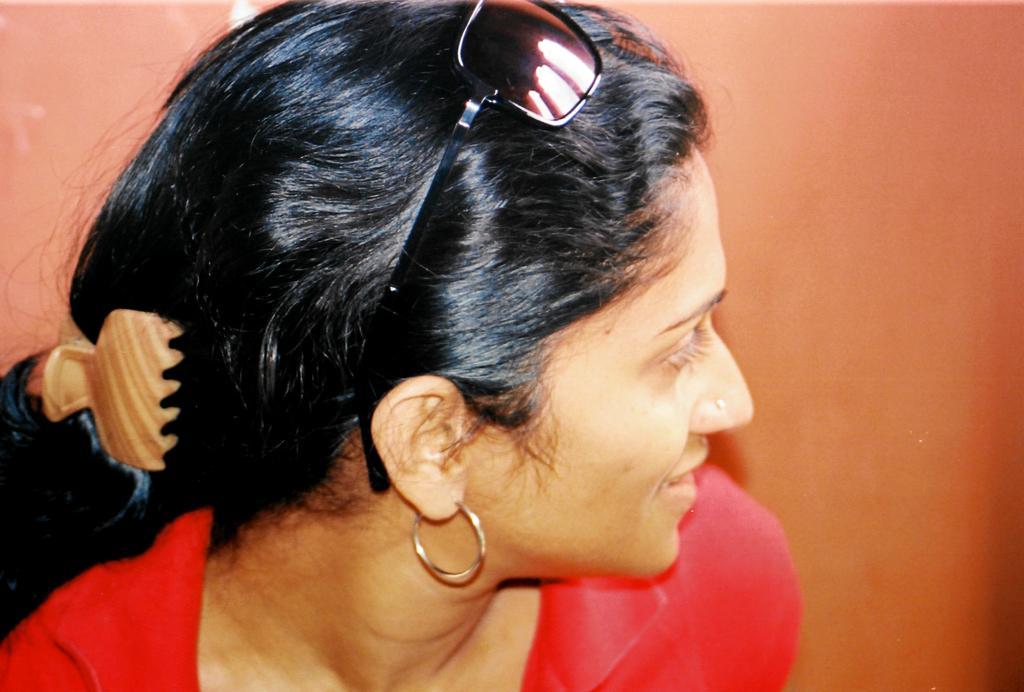Can you describe this image briefly? In this image, we can see a woman is wearing red clothes and earring. Here we can see goggles and hair clip. Background there is a wall. 